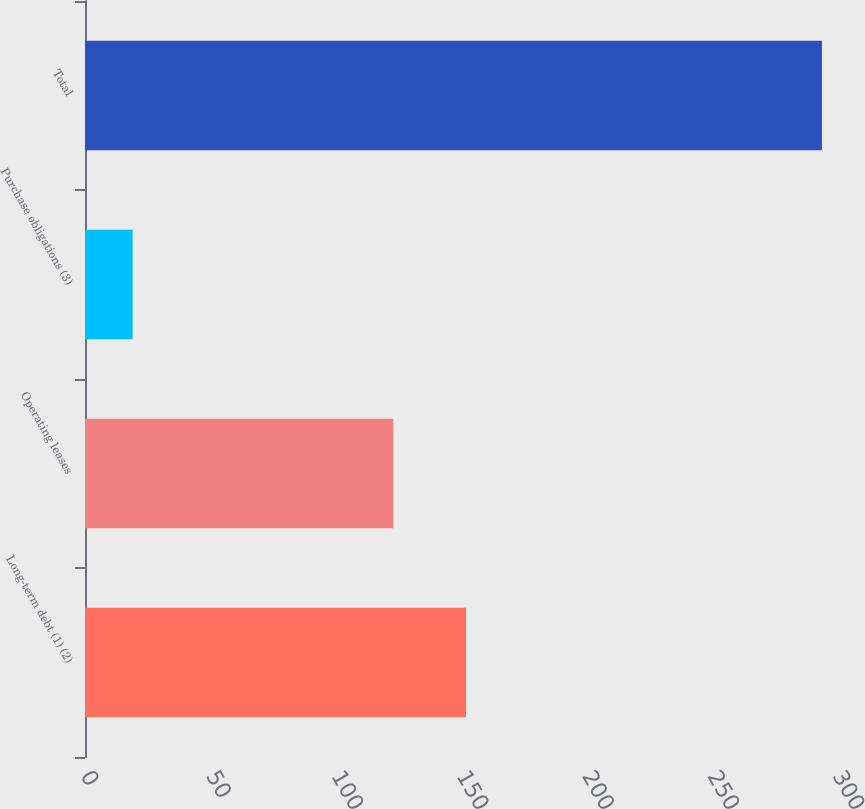<chart> <loc_0><loc_0><loc_500><loc_500><bar_chart><fcel>Long-term debt (1) (2)<fcel>Operating leases<fcel>Purchase obligations (3)<fcel>Total<nl><fcel>152<fcel>123<fcel>19<fcel>294<nl></chart> 